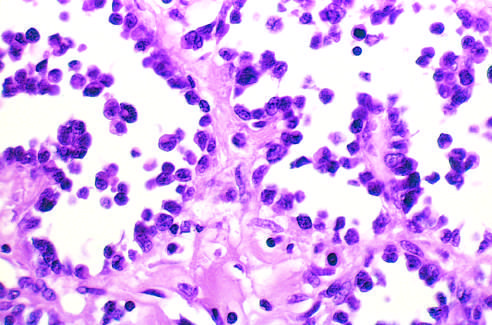s alveolar rhabdomyosarcoma with numerous spaces lined by discohesive, uniform round tumor cells?
Answer the question using a single word or phrase. Yes 